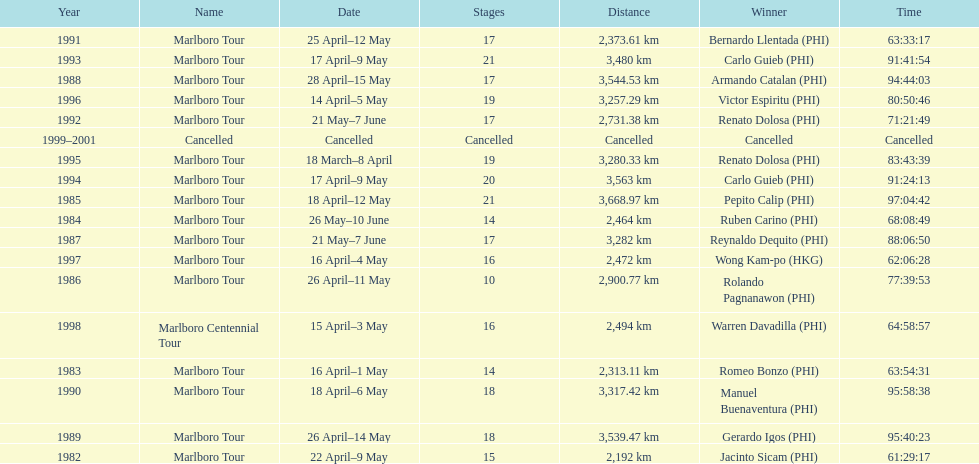Who won the most marlboro tours? Carlo Guieb. 